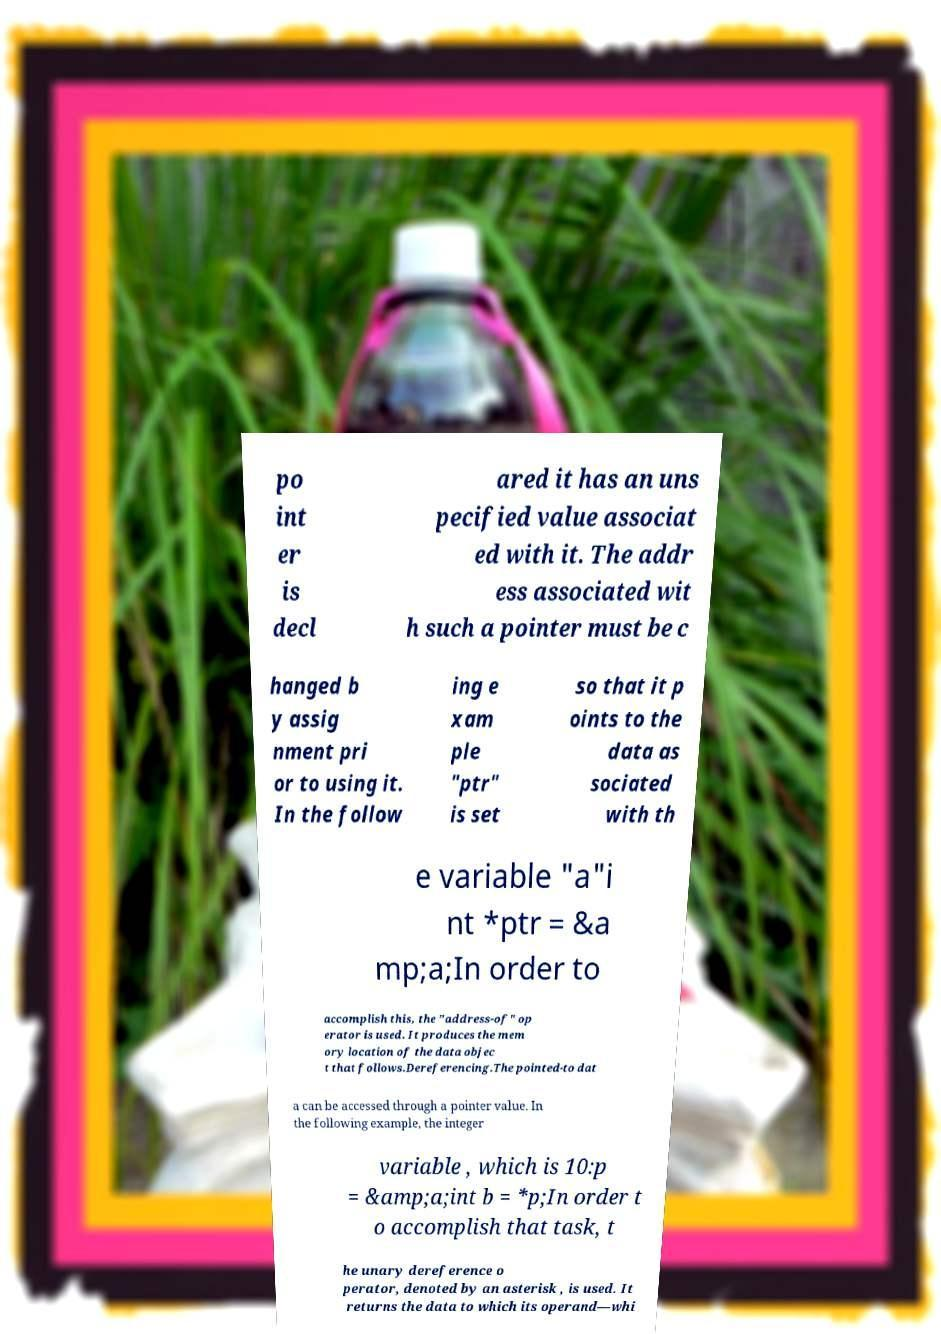Can you read and provide the text displayed in the image?This photo seems to have some interesting text. Can you extract and type it out for me? po int er is decl ared it has an uns pecified value associat ed with it. The addr ess associated wit h such a pointer must be c hanged b y assig nment pri or to using it. In the follow ing e xam ple "ptr" is set so that it p oints to the data as sociated with th e variable "a"i nt *ptr = &a mp;a;In order to accomplish this, the "address-of" op erator is used. It produces the mem ory location of the data objec t that follows.Dereferencing.The pointed-to dat a can be accessed through a pointer value. In the following example, the integer variable , which is 10:p = &amp;a;int b = *p;In order t o accomplish that task, t he unary dereference o perator, denoted by an asterisk , is used. It returns the data to which its operand—whi 